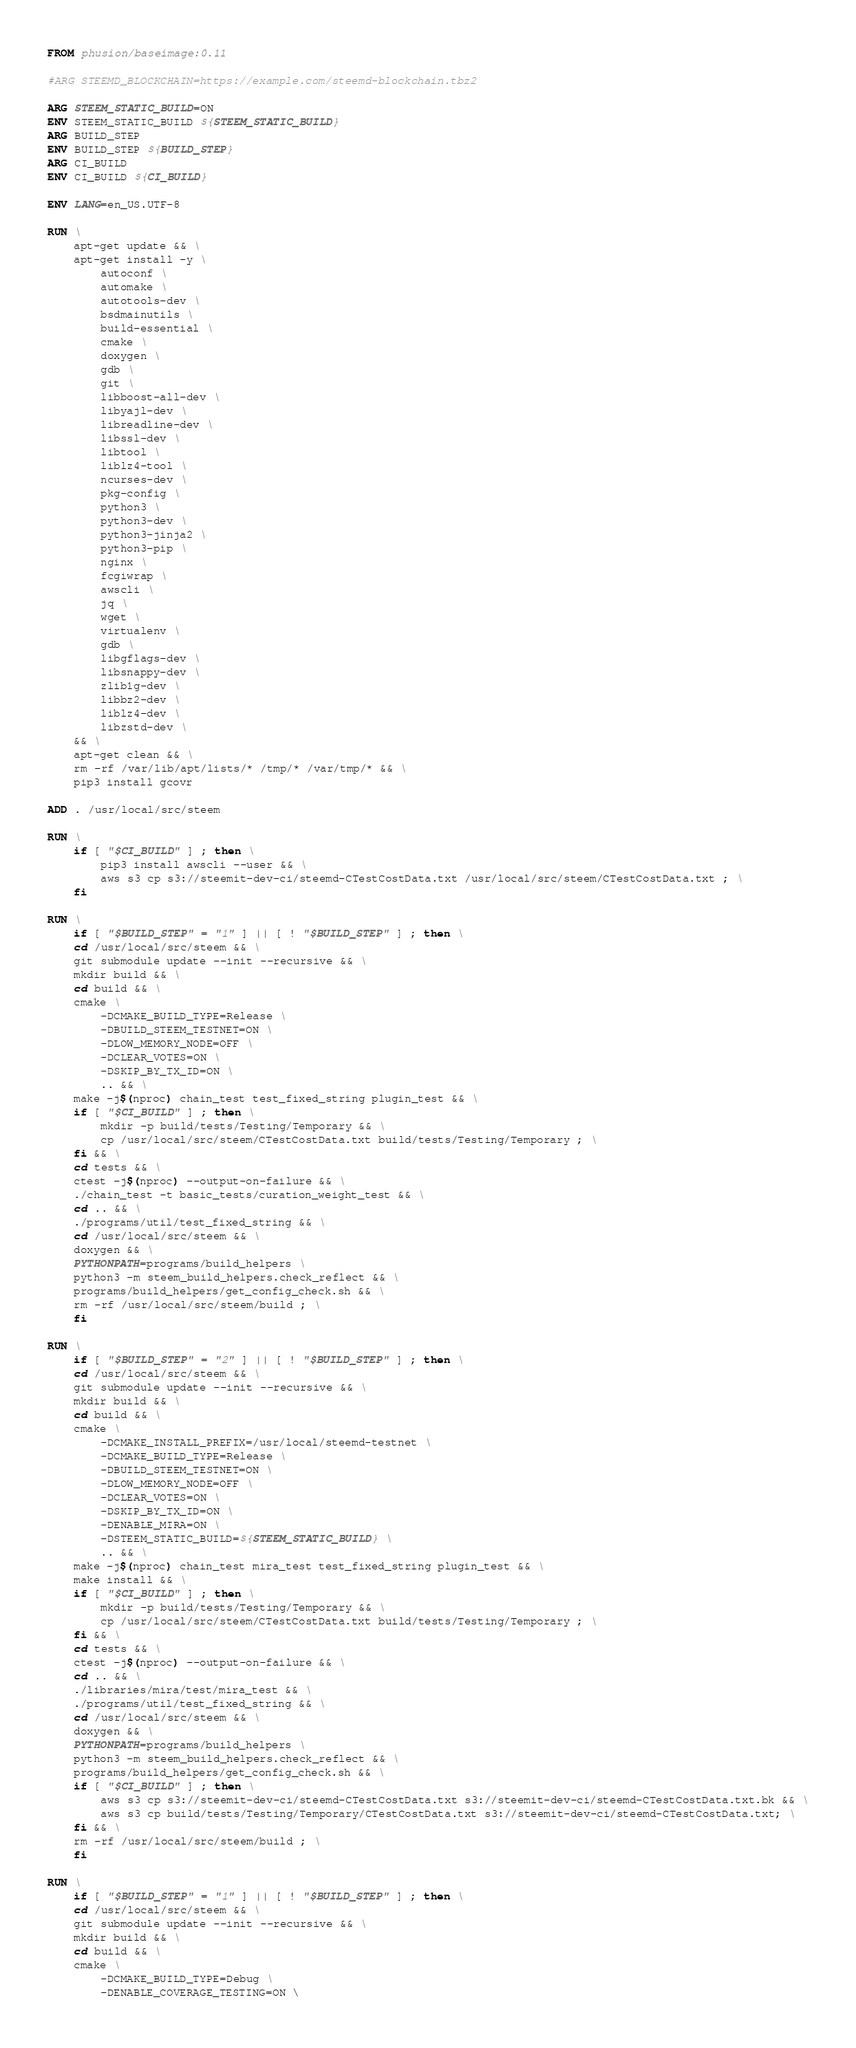<code> <loc_0><loc_0><loc_500><loc_500><_Dockerfile_>FROM phusion/baseimage:0.11

#ARG STEEMD_BLOCKCHAIN=https://example.com/steemd-blockchain.tbz2

ARG STEEM_STATIC_BUILD=ON
ENV STEEM_STATIC_BUILD ${STEEM_STATIC_BUILD}
ARG BUILD_STEP
ENV BUILD_STEP ${BUILD_STEP}
ARG CI_BUILD
ENV CI_BUILD ${CI_BUILD}

ENV LANG=en_US.UTF-8

RUN \
    apt-get update && \
    apt-get install -y \
        autoconf \
        automake \
        autotools-dev \
        bsdmainutils \
        build-essential \
        cmake \
        doxygen \
        gdb \
        git \
        libboost-all-dev \
        libyajl-dev \
        libreadline-dev \
        libssl-dev \
        libtool \
        liblz4-tool \
        ncurses-dev \
        pkg-config \
        python3 \
        python3-dev \
        python3-jinja2 \
        python3-pip \
        nginx \
        fcgiwrap \
        awscli \
        jq \
        wget \
        virtualenv \
        gdb \
        libgflags-dev \
        libsnappy-dev \
        zlib1g-dev \
        libbz2-dev \
        liblz4-dev \
        libzstd-dev \
    && \
    apt-get clean && \
    rm -rf /var/lib/apt/lists/* /tmp/* /var/tmp/* && \
    pip3 install gcovr

ADD . /usr/local/src/steem

RUN \
    if [ "$CI_BUILD" ] ; then \
        pip3 install awscli --user && \
        aws s3 cp s3://steemit-dev-ci/steemd-CTestCostData.txt /usr/local/src/steem/CTestCostData.txt ; \
    fi

RUN \
    if [ "$BUILD_STEP" = "1" ] || [ ! "$BUILD_STEP" ] ; then \
    cd /usr/local/src/steem && \
    git submodule update --init --recursive && \
    mkdir build && \
    cd build && \
    cmake \
        -DCMAKE_BUILD_TYPE=Release \
        -DBUILD_STEEM_TESTNET=ON \
        -DLOW_MEMORY_NODE=OFF \
        -DCLEAR_VOTES=ON \
        -DSKIP_BY_TX_ID=ON \
        .. && \
    make -j$(nproc) chain_test test_fixed_string plugin_test && \
    if [ "$CI_BUILD" ] ; then \
        mkdir -p build/tests/Testing/Temporary && \
        cp /usr/local/src/steem/CTestCostData.txt build/tests/Testing/Temporary ; \
    fi && \
    cd tests && \
    ctest -j$(nproc) --output-on-failure && \
    ./chain_test -t basic_tests/curation_weight_test && \
    cd .. && \
    ./programs/util/test_fixed_string && \
    cd /usr/local/src/steem && \
    doxygen && \
    PYTHONPATH=programs/build_helpers \
    python3 -m steem_build_helpers.check_reflect && \
    programs/build_helpers/get_config_check.sh && \
    rm -rf /usr/local/src/steem/build ; \
    fi

RUN \
    if [ "$BUILD_STEP" = "2" ] || [ ! "$BUILD_STEP" ] ; then \
    cd /usr/local/src/steem && \
    git submodule update --init --recursive && \
    mkdir build && \
    cd build && \
    cmake \
        -DCMAKE_INSTALL_PREFIX=/usr/local/steemd-testnet \
        -DCMAKE_BUILD_TYPE=Release \
        -DBUILD_STEEM_TESTNET=ON \
        -DLOW_MEMORY_NODE=OFF \
        -DCLEAR_VOTES=ON \
        -DSKIP_BY_TX_ID=ON \
        -DENABLE_MIRA=ON \
        -DSTEEM_STATIC_BUILD=${STEEM_STATIC_BUILD} \
        .. && \
    make -j$(nproc) chain_test mira_test test_fixed_string plugin_test && \
    make install && \
    if [ "$CI_BUILD" ] ; then \
        mkdir -p build/tests/Testing/Temporary && \
        cp /usr/local/src/steem/CTestCostData.txt build/tests/Testing/Temporary ; \
    fi && \
    cd tests && \
    ctest -j$(nproc) --output-on-failure && \
    cd .. && \
    ./libraries/mira/test/mira_test && \
    ./programs/util/test_fixed_string && \
    cd /usr/local/src/steem && \
    doxygen && \
    PYTHONPATH=programs/build_helpers \
    python3 -m steem_build_helpers.check_reflect && \
    programs/build_helpers/get_config_check.sh && \
    if [ "$CI_BUILD" ] ; then \
        aws s3 cp s3://steemit-dev-ci/steemd-CTestCostData.txt s3://steemit-dev-ci/steemd-CTestCostData.txt.bk && \
        aws s3 cp build/tests/Testing/Temporary/CTestCostData.txt s3://steemit-dev-ci/steemd-CTestCostData.txt; \
    fi && \
    rm -rf /usr/local/src/steem/build ; \
    fi

RUN \
    if [ "$BUILD_STEP" = "1" ] || [ ! "$BUILD_STEP" ] ; then \
    cd /usr/local/src/steem && \
    git submodule update --init --recursive && \
    mkdir build && \
    cd build && \
    cmake \
        -DCMAKE_BUILD_TYPE=Debug \
        -DENABLE_COVERAGE_TESTING=ON \</code> 